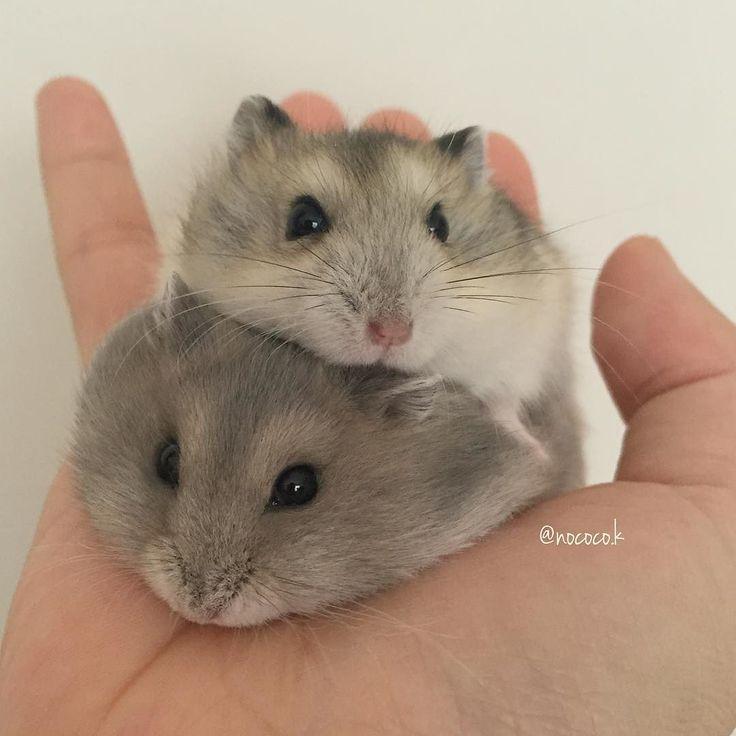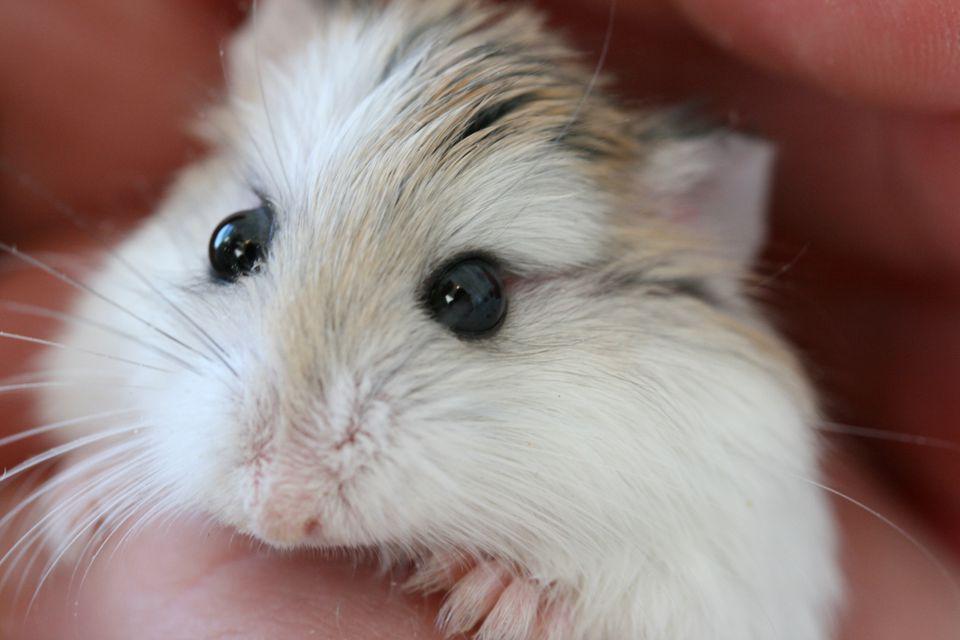The first image is the image on the left, the second image is the image on the right. Given the left and right images, does the statement "A hand is holding multiple hamsters with mottled grayish-brown fir." hold true? Answer yes or no. Yes. The first image is the image on the left, the second image is the image on the right. For the images displayed, is the sentence "The left image contains a human hand holding at least one hamster." factually correct? Answer yes or no. Yes. 